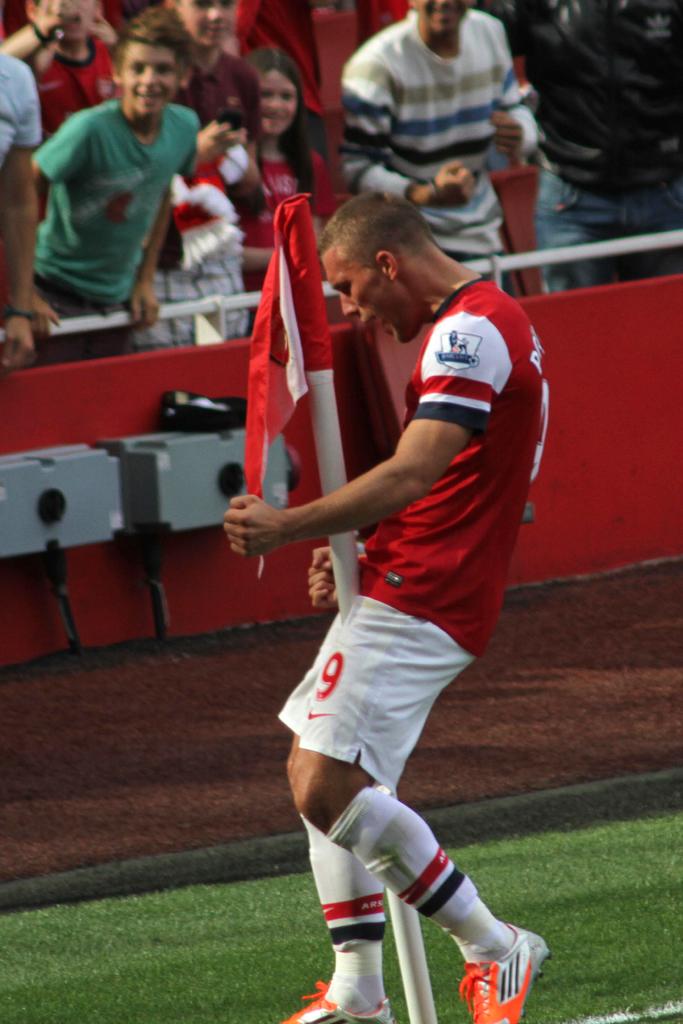Whast number is he?
Give a very brief answer. 9. 